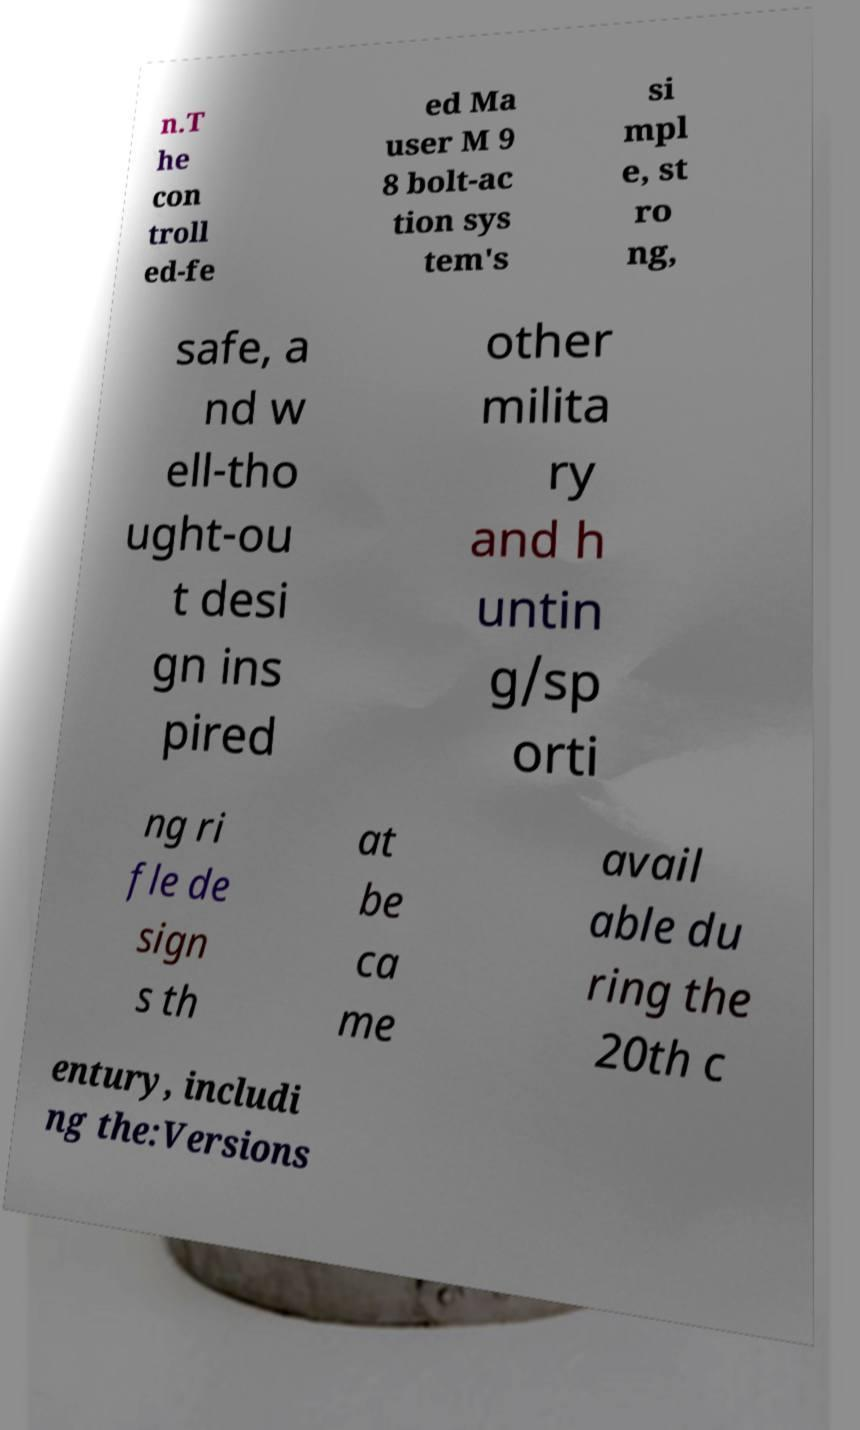Can you accurately transcribe the text from the provided image for me? n.T he con troll ed-fe ed Ma user M 9 8 bolt-ac tion sys tem's si mpl e, st ro ng, safe, a nd w ell-tho ught-ou t desi gn ins pired other milita ry and h untin g/sp orti ng ri fle de sign s th at be ca me avail able du ring the 20th c entury, includi ng the:Versions 